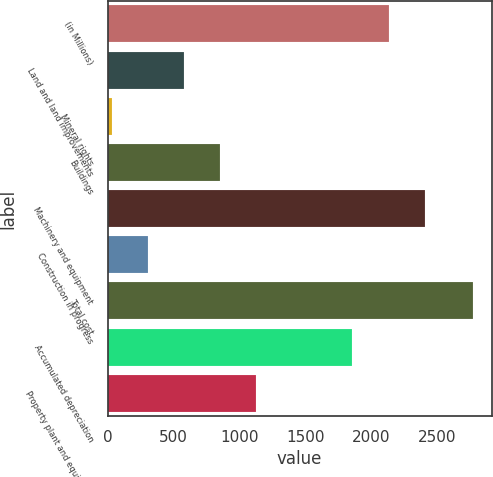<chart> <loc_0><loc_0><loc_500><loc_500><bar_chart><fcel>(in Millions)<fcel>Land and land improvements<fcel>Mineral rights<fcel>Buildings<fcel>Machinery and equipment<fcel>Construction in progress<fcel>Total cost<fcel>Accumulated depreciation<fcel>Property plant and equipment<nl><fcel>2133.28<fcel>580.56<fcel>31.4<fcel>855.14<fcel>2407.86<fcel>305.98<fcel>2777.2<fcel>1858.7<fcel>1129.72<nl></chart> 